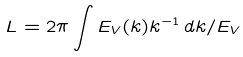<formula> <loc_0><loc_0><loc_500><loc_500>L = 2 \pi \int { E _ { V } ( k ) k ^ { - 1 } \, d k } / E _ { V }</formula> 